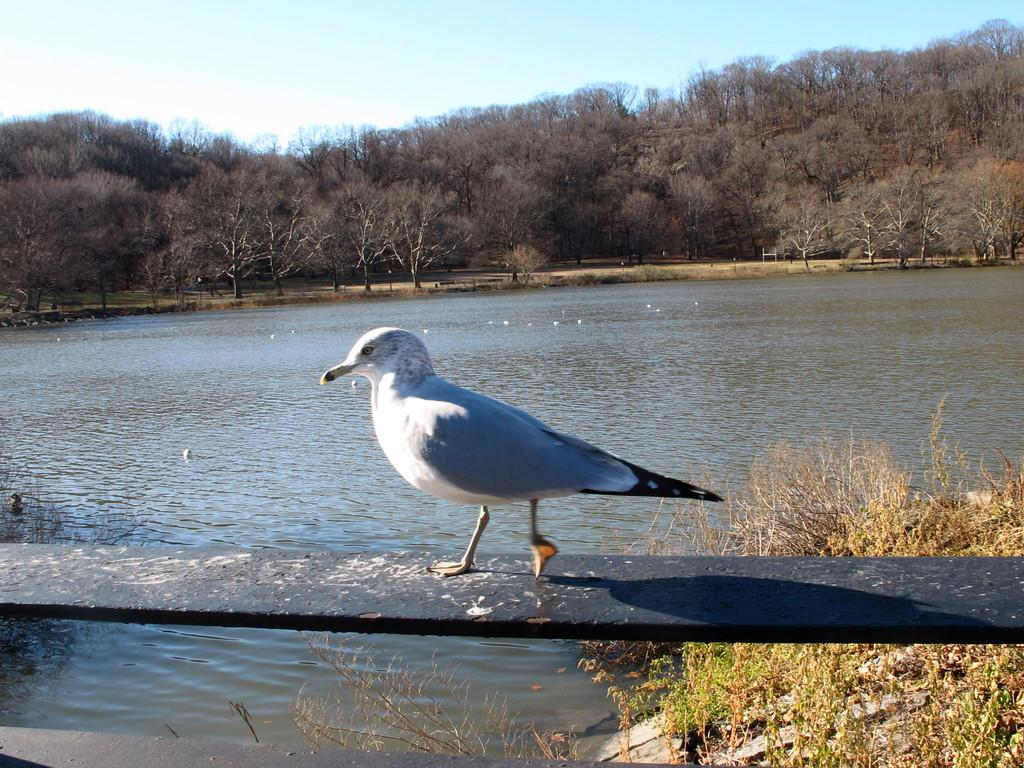What is the main subject in the foreground of the image? There is a bird in the foreground of the image. What is the bird standing on? The bird is on a wooden plank-like object. What can be seen in the foreground near the bird? There is water visible in the foreground, as well as plants. What is visible in the background of the image? There is water, trees, and the sky visible in the background. What type of gun is the bird holding in the image? There is no gun present in the image; the bird is standing on a wooden plank-like object. What color are the jeans worn by the bird in the image? There are no jeans present in the image, as the bird is a bird and not a person. 